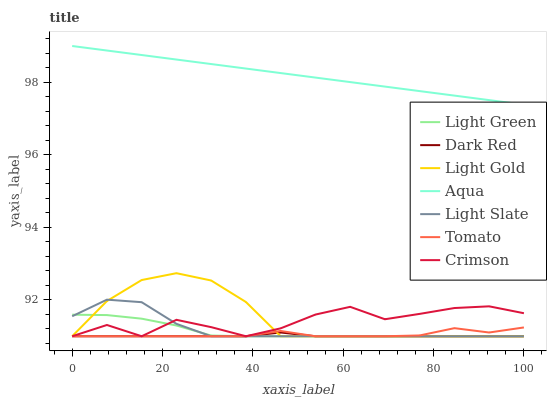Does Dark Red have the minimum area under the curve?
Answer yes or no. Yes. Does Aqua have the maximum area under the curve?
Answer yes or no. Yes. Does Light Slate have the minimum area under the curve?
Answer yes or no. No. Does Light Slate have the maximum area under the curve?
Answer yes or no. No. Is Aqua the smoothest?
Answer yes or no. Yes. Is Crimson the roughest?
Answer yes or no. Yes. Is Light Slate the smoothest?
Answer yes or no. No. Is Light Slate the roughest?
Answer yes or no. No. Does Tomato have the lowest value?
Answer yes or no. Yes. Does Aqua have the lowest value?
Answer yes or no. No. Does Aqua have the highest value?
Answer yes or no. Yes. Does Light Slate have the highest value?
Answer yes or no. No. Is Light Gold less than Aqua?
Answer yes or no. Yes. Is Aqua greater than Light Slate?
Answer yes or no. Yes. Does Light Gold intersect Light Slate?
Answer yes or no. Yes. Is Light Gold less than Light Slate?
Answer yes or no. No. Is Light Gold greater than Light Slate?
Answer yes or no. No. Does Light Gold intersect Aqua?
Answer yes or no. No. 